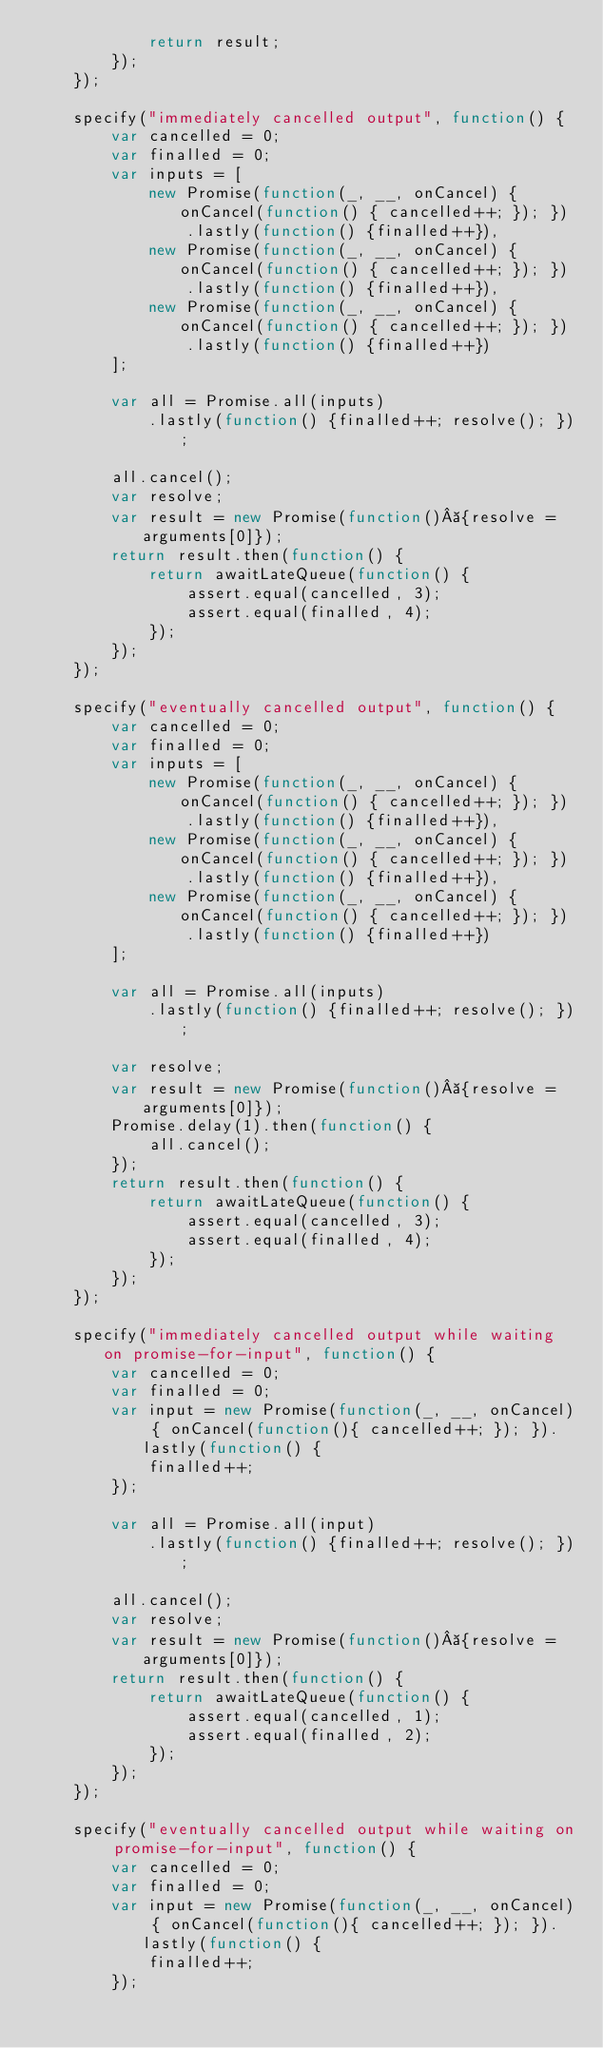<code> <loc_0><loc_0><loc_500><loc_500><_JavaScript_>            return result;
        });
    });

    specify("immediately cancelled output", function() {
        var cancelled = 0;
        var finalled = 0;
        var inputs = [
            new Promise(function(_, __, onCancel) { onCancel(function() { cancelled++; }); })
                .lastly(function() {finalled++}),
            new Promise(function(_, __, onCancel) { onCancel(function() { cancelled++; }); })
                .lastly(function() {finalled++}),
            new Promise(function(_, __, onCancel) { onCancel(function() { cancelled++; }); })
                .lastly(function() {finalled++})
        ];

        var all = Promise.all(inputs)
            .lastly(function() {finalled++; resolve(); });

        all.cancel();
        var resolve;
        var result = new Promise(function() {resolve = arguments[0]});
        return result.then(function() {
            return awaitLateQueue(function() {
                assert.equal(cancelled, 3);
                assert.equal(finalled, 4);
            });
        });
    });

    specify("eventually cancelled output", function() {
        var cancelled = 0;
        var finalled = 0;
        var inputs = [
            new Promise(function(_, __, onCancel) { onCancel(function() { cancelled++; }); })
                .lastly(function() {finalled++}),
            new Promise(function(_, __, onCancel) { onCancel(function() { cancelled++; }); })
                .lastly(function() {finalled++}),
            new Promise(function(_, __, onCancel) { onCancel(function() { cancelled++; }); })
                .lastly(function() {finalled++})
        ];

        var all = Promise.all(inputs)
            .lastly(function() {finalled++; resolve(); });

        var resolve;
        var result = new Promise(function() {resolve = arguments[0]});
        Promise.delay(1).then(function() {
            all.cancel();
        });
        return result.then(function() {
            return awaitLateQueue(function() {
                assert.equal(cancelled, 3);
                assert.equal(finalled, 4);
            });
        });
    });

    specify("immediately cancelled output while waiting on promise-for-input", function() {
        var cancelled = 0;
        var finalled = 0;
        var input = new Promise(function(_, __, onCancel) { onCancel(function(){ cancelled++; }); }).lastly(function() {
            finalled++;
        });

        var all = Promise.all(input)
            .lastly(function() {finalled++; resolve(); });

        all.cancel();
        var resolve;
        var result = new Promise(function() {resolve = arguments[0]});
        return result.then(function() {
            return awaitLateQueue(function() {
                assert.equal(cancelled, 1);
                assert.equal(finalled, 2);
            });
        });
    });

    specify("eventually cancelled output while waiting on promise-for-input", function() {
        var cancelled = 0;
        var finalled = 0;
        var input = new Promise(function(_, __, onCancel) { onCancel(function(){ cancelled++; }); }).lastly(function() {
            finalled++;
        });
</code> 